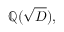Convert formula to latex. <formula><loc_0><loc_0><loc_500><loc_500>\mathbb { Q } ( { \sqrt { D } } ) ,</formula> 